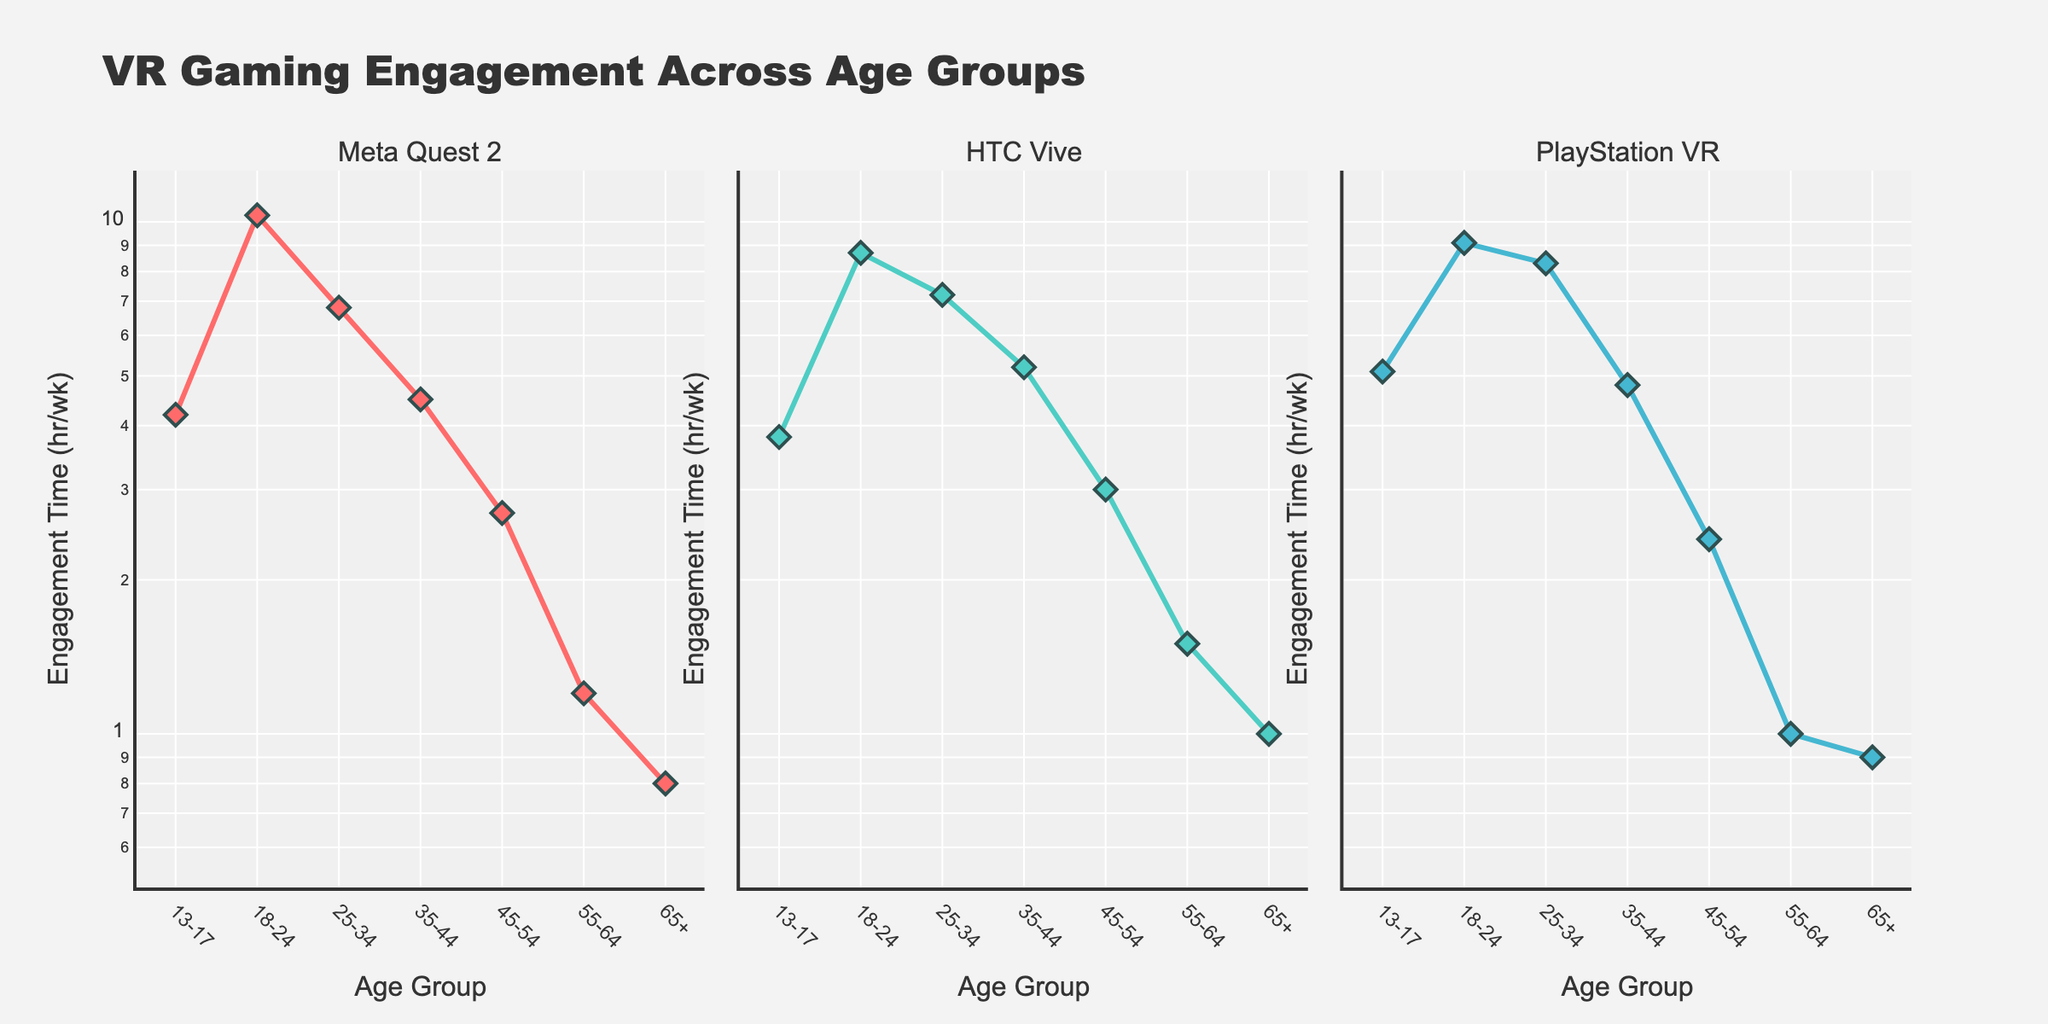What is the title of the figure? The title of the figure is displayed prominently at the top.
Answer: VR Gaming Engagement Across Age Groups What are the age groups represented in the plot? The x-axis labels show the age groups.
Answer: 13-17, 18-24, 25-34, 35-44, 45-54, 55-64, 65+ Which platform has the highest engagement time for the 18-24 age group? From the subplot for each platform, the curves show engagement time per age group. Meta Quest 2 for 18-24 has the highest engagement time.
Answer: Meta Quest 2 Does engagement time generally increase or decrease as age increases? Observing each subplot, the trend shows a decrease in engagement time as the age group increases.
Answer: Decrease Which age group has the lowest engagement time for all platforms? All subplots consistently show the least engagement time in the 65+ age group.
Answer: 65+ Which platform shows the smallest difference in engagement time between the 13-17 and 18-24 age groups? Comparing the gaps between the 13-17 and 18-24 age groups in each subplot, PlayStation VR shows the smallest difference.
Answer: PlayStation VR How does the engagement time for 45-54 compare to 55-64 in the Meta Quest 2 subplot? For Meta Quest 2, the engagement time for 45-54 is about twice as much as 55-64.
Answer: Greater Which age group uses the HTC Vive platform most frequently? The highest point on the HTC Vive subplot corresponds with the 18-24 age group.
Answer: 18-24 Is the difference in engagement time between 25-34 and 35-44 significant for PlayStation VR? Examining the PlayStation VR subplot, the difference between 25-34 and 35-44 is relatively small, indicating it is not significant.
Answer: No What trend can be observed in engagement time for PlayStation VR from 13-17 to 65+ years? The PlayStation VR subplot shows a general downward trend from the younger age groups to the older ones.
Answer: Decrease 